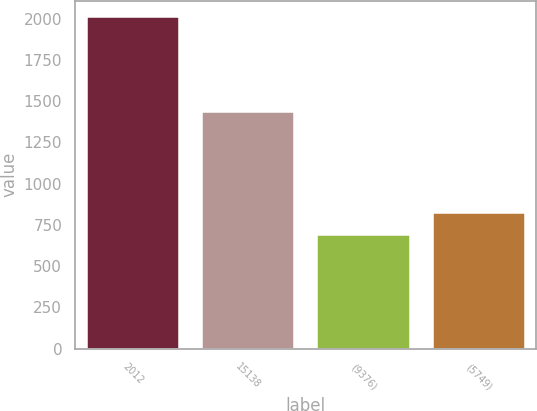Convert chart. <chart><loc_0><loc_0><loc_500><loc_500><bar_chart><fcel>2012<fcel>15138<fcel>(9376)<fcel>(5749)<nl><fcel>2010<fcel>1433.7<fcel>690.5<fcel>822.45<nl></chart> 